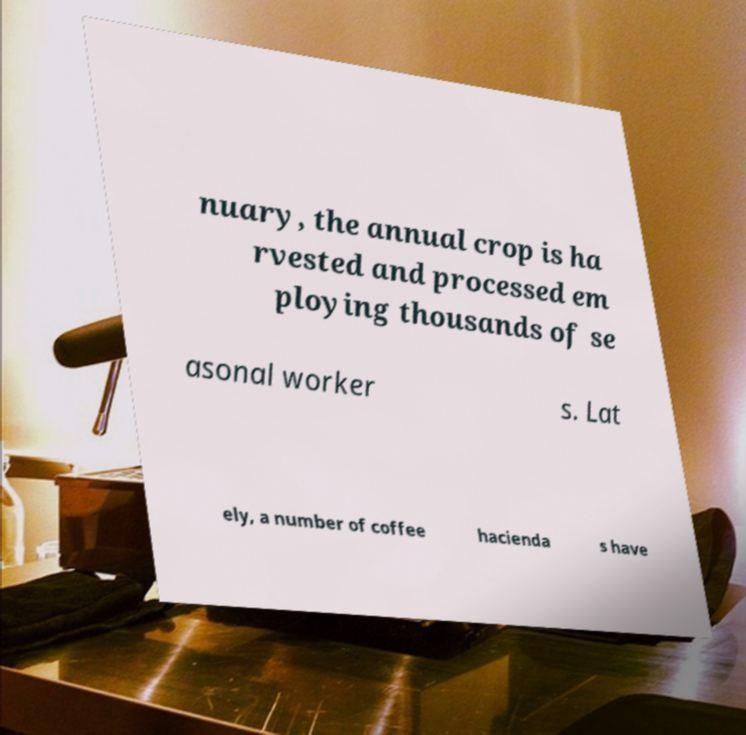Please identify and transcribe the text found in this image. nuary, the annual crop is ha rvested and processed em ploying thousands of se asonal worker s. Lat ely, a number of coffee hacienda s have 